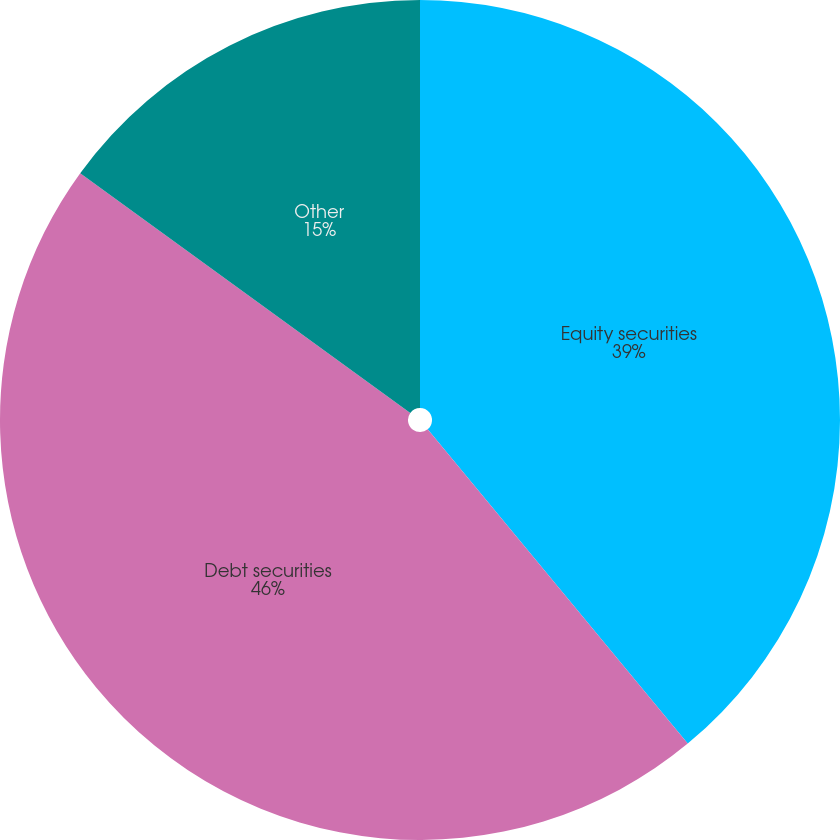<chart> <loc_0><loc_0><loc_500><loc_500><pie_chart><fcel>Equity securities<fcel>Debt securities<fcel>Other<nl><fcel>39.0%<fcel>46.0%<fcel>15.0%<nl></chart> 